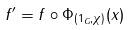Convert formula to latex. <formula><loc_0><loc_0><loc_500><loc_500>f ^ { \prime } = f \circ \Phi _ { ( 1 _ { G } , \chi ) } ( x )</formula> 